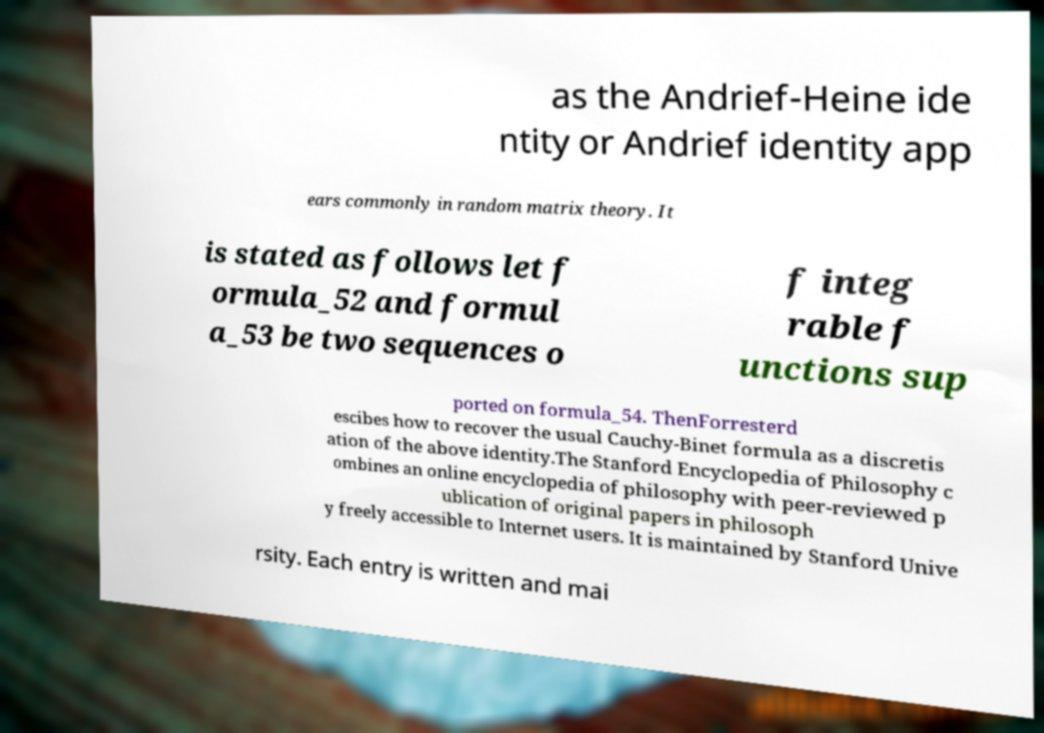Please identify and transcribe the text found in this image. as the Andrief-Heine ide ntity or Andrief identity app ears commonly in random matrix theory. It is stated as follows let f ormula_52 and formul a_53 be two sequences o f integ rable f unctions sup ported on formula_54. ThenForresterd escibes how to recover the usual Cauchy-Binet formula as a discretis ation of the above identity.The Stanford Encyclopedia of Philosophy c ombines an online encyclopedia of philosophy with peer-reviewed p ublication of original papers in philosoph y freely accessible to Internet users. It is maintained by Stanford Unive rsity. Each entry is written and mai 